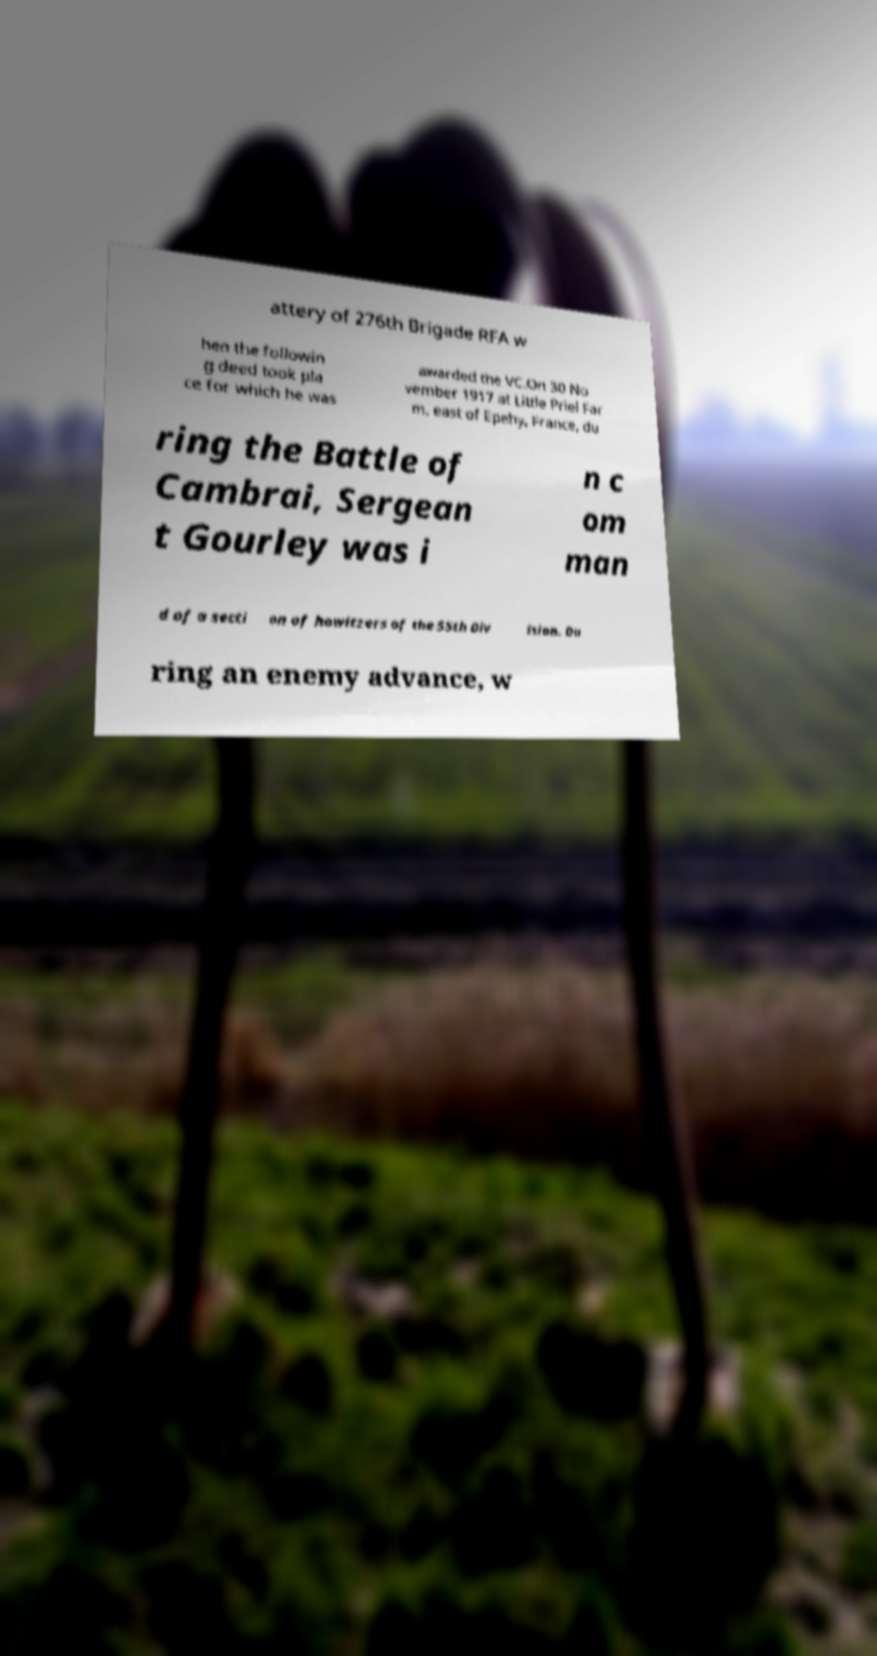Could you assist in decoding the text presented in this image and type it out clearly? attery of 276th Brigade RFA w hen the followin g deed took pla ce for which he was awarded the VC.On 30 No vember 1917 at Little Priel Far m, east of Epehy, France, du ring the Battle of Cambrai, Sergean t Gourley was i n c om man d of a secti on of howitzers of the 55th Div ision. Du ring an enemy advance, w 